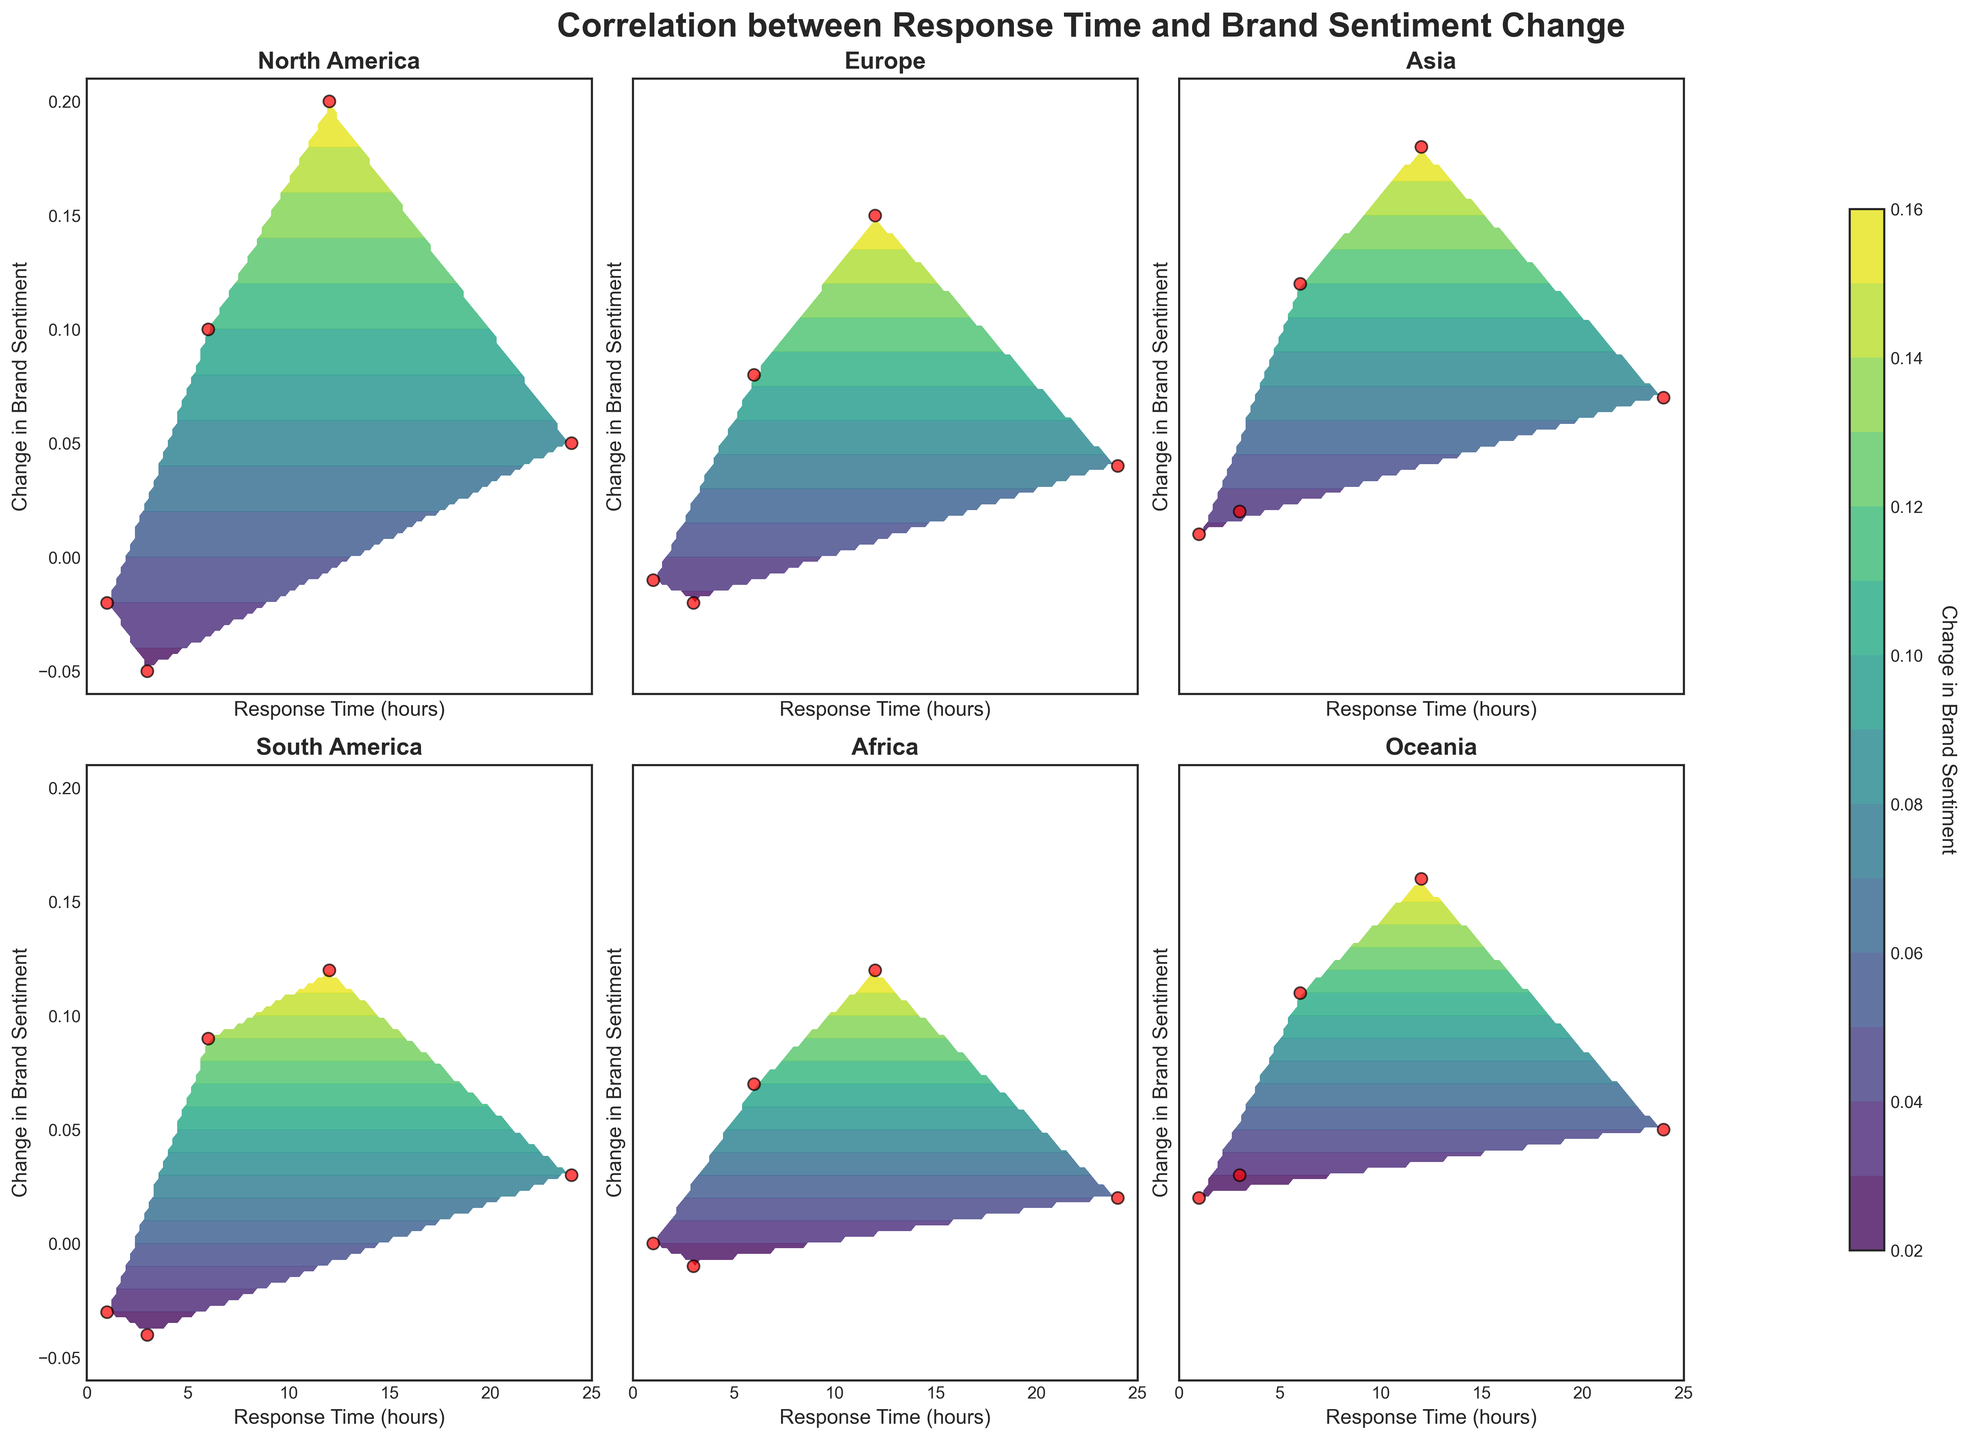What is the general trend of change in brand sentiment with increasing response time across all regions? The contour plots generally show that as response time increases, especially beyond 6 hours, there is a noticeable increase in positive change to brand sentiment. Regions like Asia, Oceania, and North America clearly exhibit positive sentiment change with longer response times.
Answer: Positive trend Which region shows the highest positive change in brand sentiment at the shortest response time? By observing the initial contour levels for each region, Oceania shows the highest positive change in brand sentiment with a short response time of 1 hour.
Answer: Oceania At what response time does Europe show a positive change in brand sentiment? Looking at the contour levels and scatter points for Europe, the positive change in brand sentiment occurs starting from a 6-hour response time onwards.
Answer: 6 hours How does North America's brand sentiment change at a 24-hour response time compared to Asia's? North America's brand sentiment change at a 24-hour response time is around 0.05, while Asia shows a higher positive sentiment change of approximately 0.07.
Answer: Asia has a higher change What is the range of brand sentiment change for Africa's contour plot? The contour plot for Africa displays changes in brand sentiment ranging from -0.01 to approximately 0.12.
Answer: -0.01 to 0.12 Which region depicted in the contour plots shows the most significant negative change in brand sentiment for response times of 1-3 hours? By examining the contour plots, South America displays the most significant negative change in brand sentiment for response times between 1 to 3 hours, as indicated by the darker shading.
Answer: South America Do any regions exhibit a negative change in brand sentiment for response times of 12 hours or more? Looking at all the contour plots, none of the regions show a negative change in brand sentiment for response times of 12 hours or more. All regions exhibit positive sentiment changes.
Answer: No Which region has the most data points indicated by red scatter points on the contour plot? By counting the red scatter points for each region's contour plot, all regions have the same number of data points, with each having 5 points.
Answer: Equal data points Compare the change in brand sentiment for North America and Europe at a 6-hour response time. North America's change in brand sentiment at a 6-hour response time is approximately 0.10, while Europe's change is slightly lower at around 0.08.
Answer: North America What does the color bar represent in the contour plots? The color bar located on the right side of the figurers indicates the gradient of the change in brand sentiment. Higher positive changes are represented by lighter colors.
Answer: Change in brand sentiment 